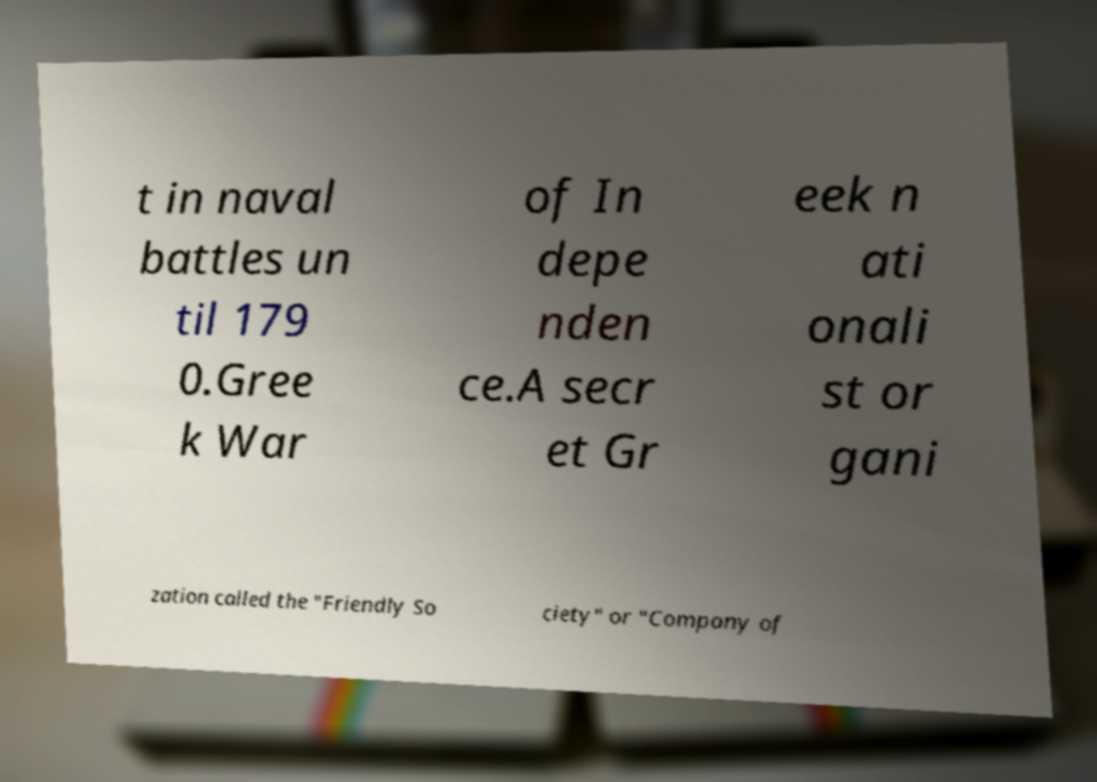What messages or text are displayed in this image? I need them in a readable, typed format. t in naval battles un til 179 0.Gree k War of In depe nden ce.A secr et Gr eek n ati onali st or gani zation called the "Friendly So ciety" or "Company of 